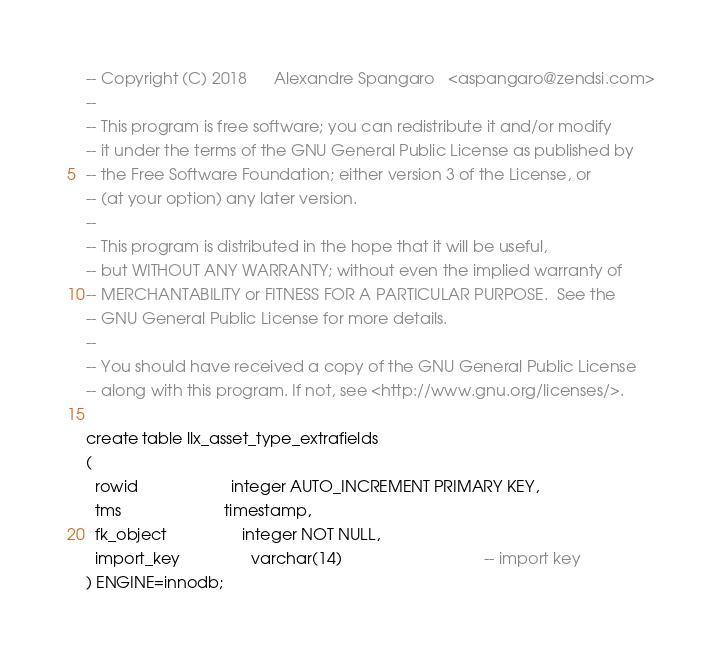<code> <loc_0><loc_0><loc_500><loc_500><_SQL_>-- Copyright (C) 2018      Alexandre Spangaro   <aspangaro@zendsi.com>
--
-- This program is free software; you can redistribute it and/or modify
-- it under the terms of the GNU General Public License as published by
-- the Free Software Foundation; either version 3 of the License, or
-- (at your option) any later version.
--
-- This program is distributed in the hope that it will be useful,
-- but WITHOUT ANY WARRANTY; without even the implied warranty of
-- MERCHANTABILITY or FITNESS FOR A PARTICULAR PURPOSE.  See the
-- GNU General Public License for more details.
--
-- You should have received a copy of the GNU General Public License
-- along with this program. If not, see <http://www.gnu.org/licenses/>.

create table llx_asset_type_extrafields
(
  rowid                     integer AUTO_INCREMENT PRIMARY KEY,
  tms                       timestamp,
  fk_object                 integer NOT NULL,
  import_key                varchar(14)                          		-- import key
) ENGINE=innodb;

</code> 